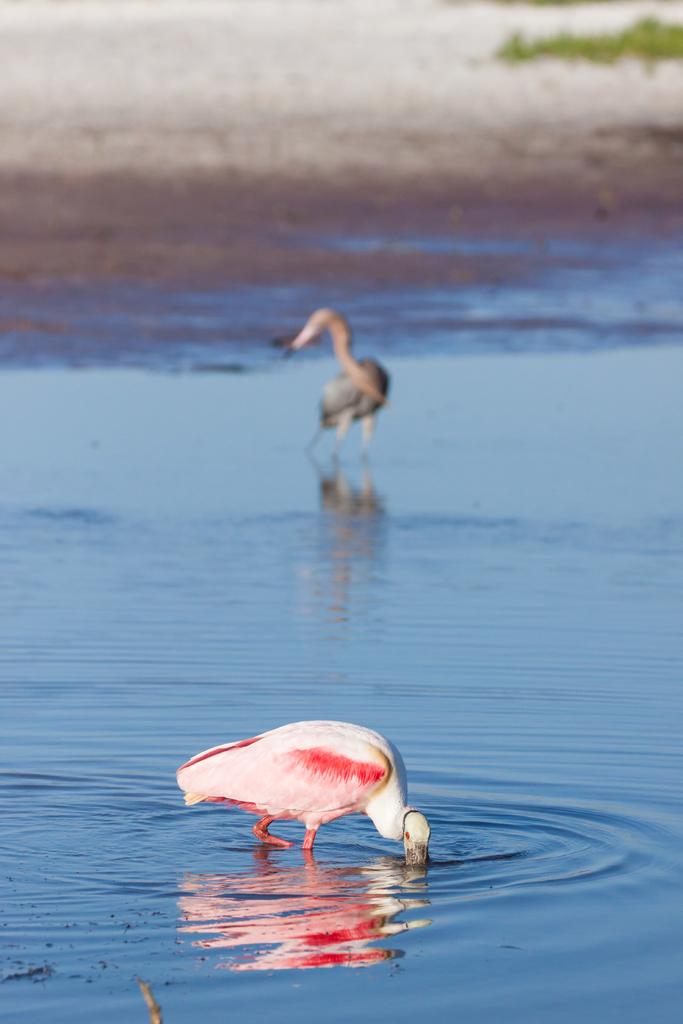How many birds are in the image? There are two birds in the image. Where are the birds located in the image? The birds are in the water. What type of environment is depicted in the image? The image shows water, sand, and grass, suggesting a beach or shoreline setting. What type of competition are the birds participating in within the image? There is no competition present in the image; the birds are simply in the water. Can you tell me if the birds have a friend with them in the image? The image does not provide information about the birds' relationships or companions, so it cannot be determined if they have a friend with them. 